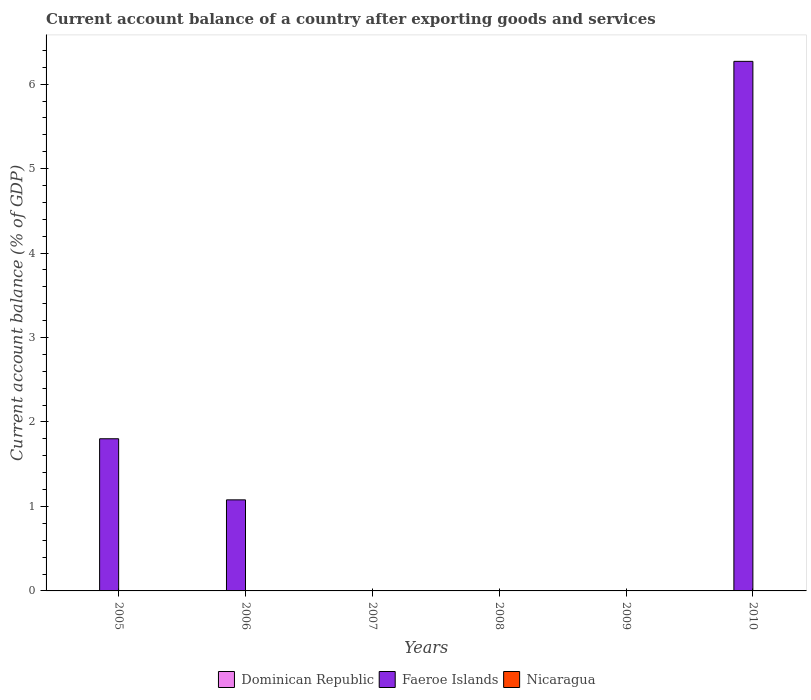Are the number of bars per tick equal to the number of legend labels?
Offer a terse response. No. Are the number of bars on each tick of the X-axis equal?
Provide a succinct answer. No. In how many cases, is the number of bars for a given year not equal to the number of legend labels?
Your answer should be very brief. 6. What is the account balance in Nicaragua in 2005?
Ensure brevity in your answer.  0. Across all years, what is the maximum account balance in Faeroe Islands?
Your response must be concise. 6.27. What is the total account balance in Dominican Republic in the graph?
Keep it short and to the point. 0. What is the difference between the account balance in Faeroe Islands in 2005 and that in 2006?
Give a very brief answer. 0.72. What is the average account balance in Dominican Republic per year?
Provide a succinct answer. 0. In how many years, is the account balance in Faeroe Islands greater than 6 %?
Provide a short and direct response. 1. Is the account balance in Faeroe Islands in 2006 less than that in 2010?
Provide a short and direct response. Yes. What is the difference between the highest and the second highest account balance in Faeroe Islands?
Make the answer very short. 4.47. What is the difference between the highest and the lowest account balance in Faeroe Islands?
Keep it short and to the point. 6.27. Is it the case that in every year, the sum of the account balance in Dominican Republic and account balance in Faeroe Islands is greater than the account balance in Nicaragua?
Give a very brief answer. No. Does the graph contain grids?
Your answer should be very brief. No. How many legend labels are there?
Offer a very short reply. 3. What is the title of the graph?
Make the answer very short. Current account balance of a country after exporting goods and services. Does "Eritrea" appear as one of the legend labels in the graph?
Your response must be concise. No. What is the label or title of the Y-axis?
Give a very brief answer. Current account balance (% of GDP). What is the Current account balance (% of GDP) in Faeroe Islands in 2005?
Provide a succinct answer. 1.8. What is the Current account balance (% of GDP) of Faeroe Islands in 2006?
Offer a terse response. 1.08. What is the Current account balance (% of GDP) in Nicaragua in 2006?
Ensure brevity in your answer.  0. What is the Current account balance (% of GDP) in Dominican Republic in 2007?
Ensure brevity in your answer.  0. What is the Current account balance (% of GDP) of Faeroe Islands in 2007?
Keep it short and to the point. 0. What is the Current account balance (% of GDP) in Nicaragua in 2007?
Offer a very short reply. 0. What is the Current account balance (% of GDP) of Nicaragua in 2008?
Provide a succinct answer. 0. What is the Current account balance (% of GDP) of Dominican Republic in 2009?
Offer a very short reply. 0. What is the Current account balance (% of GDP) of Faeroe Islands in 2009?
Provide a short and direct response. 0. What is the Current account balance (% of GDP) in Faeroe Islands in 2010?
Make the answer very short. 6.27. Across all years, what is the maximum Current account balance (% of GDP) in Faeroe Islands?
Provide a short and direct response. 6.27. Across all years, what is the minimum Current account balance (% of GDP) in Faeroe Islands?
Ensure brevity in your answer.  0. What is the total Current account balance (% of GDP) in Faeroe Islands in the graph?
Your response must be concise. 9.15. What is the total Current account balance (% of GDP) of Nicaragua in the graph?
Your response must be concise. 0. What is the difference between the Current account balance (% of GDP) in Faeroe Islands in 2005 and that in 2006?
Your response must be concise. 0.72. What is the difference between the Current account balance (% of GDP) in Faeroe Islands in 2005 and that in 2010?
Give a very brief answer. -4.47. What is the difference between the Current account balance (% of GDP) of Faeroe Islands in 2006 and that in 2010?
Provide a short and direct response. -5.19. What is the average Current account balance (% of GDP) of Dominican Republic per year?
Give a very brief answer. 0. What is the average Current account balance (% of GDP) of Faeroe Islands per year?
Your answer should be compact. 1.52. What is the ratio of the Current account balance (% of GDP) in Faeroe Islands in 2005 to that in 2006?
Keep it short and to the point. 1.67. What is the ratio of the Current account balance (% of GDP) in Faeroe Islands in 2005 to that in 2010?
Your answer should be very brief. 0.29. What is the ratio of the Current account balance (% of GDP) of Faeroe Islands in 2006 to that in 2010?
Provide a succinct answer. 0.17. What is the difference between the highest and the second highest Current account balance (% of GDP) of Faeroe Islands?
Make the answer very short. 4.47. What is the difference between the highest and the lowest Current account balance (% of GDP) in Faeroe Islands?
Ensure brevity in your answer.  6.27. 